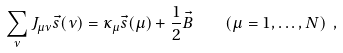Convert formula to latex. <formula><loc_0><loc_0><loc_500><loc_500>\sum _ { \nu } J _ { \mu \nu } \vec { s } ( \nu ) = \kappa _ { \mu } \vec { s } ( \mu ) + \frac { 1 } { 2 } \vec { B } \quad ( \mu = 1 , \dots , N ) \ ,</formula> 